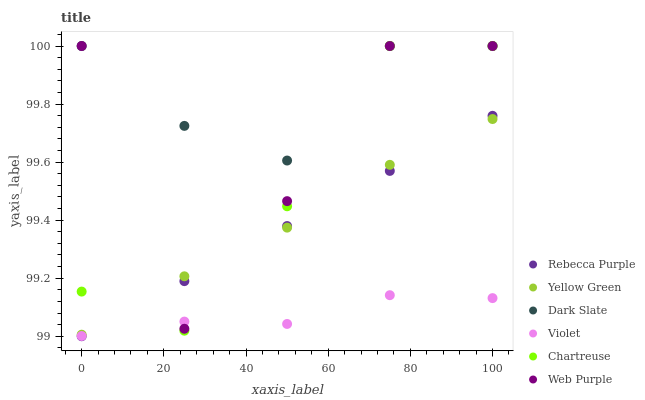Does Violet have the minimum area under the curve?
Answer yes or no. Yes. Does Dark Slate have the maximum area under the curve?
Answer yes or no. Yes. Does Web Purple have the minimum area under the curve?
Answer yes or no. No. Does Web Purple have the maximum area under the curve?
Answer yes or no. No. Is Rebecca Purple the smoothest?
Answer yes or no. Yes. Is Web Purple the roughest?
Answer yes or no. Yes. Is Dark Slate the smoothest?
Answer yes or no. No. Is Dark Slate the roughest?
Answer yes or no. No. Does Rebecca Purple have the lowest value?
Answer yes or no. Yes. Does Web Purple have the lowest value?
Answer yes or no. No. Does Chartreuse have the highest value?
Answer yes or no. Yes. Does Rebecca Purple have the highest value?
Answer yes or no. No. Is Violet less than Yellow Green?
Answer yes or no. Yes. Is Dark Slate greater than Rebecca Purple?
Answer yes or no. Yes. Does Web Purple intersect Violet?
Answer yes or no. Yes. Is Web Purple less than Violet?
Answer yes or no. No. Is Web Purple greater than Violet?
Answer yes or no. No. Does Violet intersect Yellow Green?
Answer yes or no. No. 